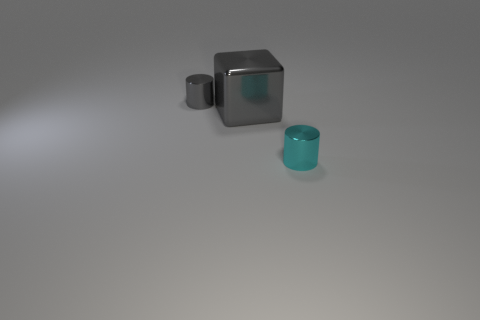Add 2 big cyan shiny balls. How many objects exist? 5 Subtract 1 cyan cylinders. How many objects are left? 2 Subtract all cubes. How many objects are left? 2 Subtract all red blocks. Subtract all cyan cylinders. How many blocks are left? 1 Subtract all cyan objects. Subtract all cyan shiny cylinders. How many objects are left? 1 Add 1 blocks. How many blocks are left? 2 Add 3 small gray metallic cylinders. How many small gray metallic cylinders exist? 4 